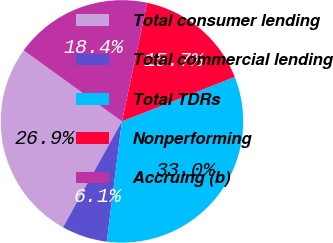<chart> <loc_0><loc_0><loc_500><loc_500><pie_chart><fcel>Total consumer lending<fcel>Total commercial lending<fcel>Total TDRs<fcel>Nonperforming<fcel>Accruing (b)<nl><fcel>26.88%<fcel>6.09%<fcel>32.97%<fcel>15.69%<fcel>18.38%<nl></chart> 